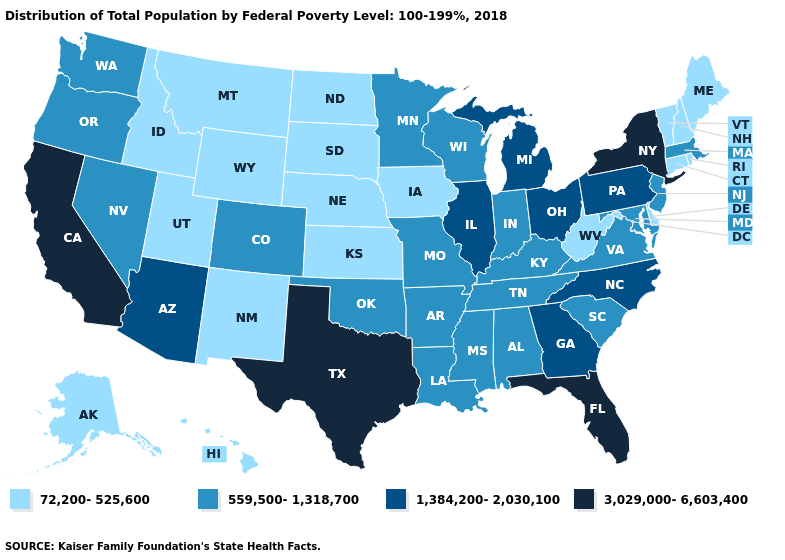Among the states that border New Hampshire , does Massachusetts have the highest value?
Quick response, please. Yes. Does the first symbol in the legend represent the smallest category?
Quick response, please. Yes. Is the legend a continuous bar?
Quick response, please. No. Among the states that border Arkansas , which have the lowest value?
Short answer required. Louisiana, Mississippi, Missouri, Oklahoma, Tennessee. How many symbols are there in the legend?
Give a very brief answer. 4. Does West Virginia have the same value as Florida?
Give a very brief answer. No. Does Ohio have the same value as Alabama?
Keep it brief. No. Does California have the highest value in the USA?
Answer briefly. Yes. What is the lowest value in the USA?
Short answer required. 72,200-525,600. Is the legend a continuous bar?
Keep it brief. No. Does California have the highest value in the West?
Quick response, please. Yes. Does the first symbol in the legend represent the smallest category?
Concise answer only. Yes. What is the lowest value in the USA?
Quick response, please. 72,200-525,600. What is the value of Alaska?
Write a very short answer. 72,200-525,600. Does Indiana have the lowest value in the MidWest?
Concise answer only. No. 